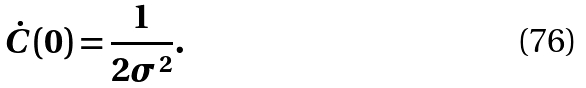<formula> <loc_0><loc_0><loc_500><loc_500>\dot { C } ( 0 ) = \frac { 1 } { 2 \sigma ^ { 2 } } .</formula> 